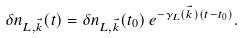<formula> <loc_0><loc_0><loc_500><loc_500>\delta n _ { L , { \vec { k } } } ( t ) = \delta n _ { L , { \vec { k } } } ( t _ { 0 } ) \, e ^ { - \gamma _ { L } ( { \vec { k } } ) ( t - t _ { 0 } ) } .</formula> 